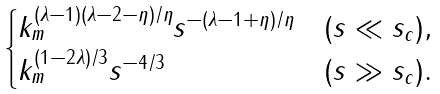Convert formula to latex. <formula><loc_0><loc_0><loc_500><loc_500>\begin{cases} k _ { m } ^ { ( \lambda - 1 ) ( \lambda - 2 - \eta ) / \eta } s ^ { - ( \lambda - 1 + \eta ) / \eta } & ( s \ll s _ { c } ) , \\ k _ { m } ^ { ( 1 - 2 \lambda ) / 3 } s ^ { - 4 / 3 } & ( s \gg s _ { c } ) . \end{cases}</formula> 